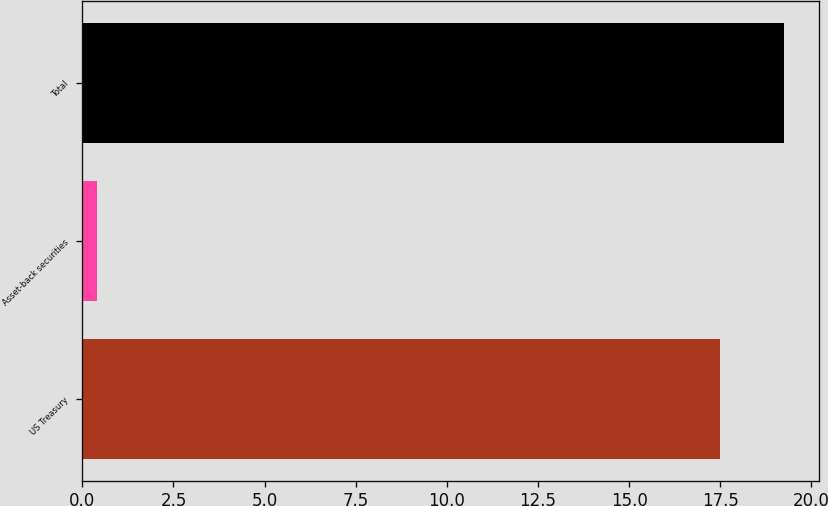Convert chart to OTSL. <chart><loc_0><loc_0><loc_500><loc_500><bar_chart><fcel>US Treasury<fcel>Asset-back securities<fcel>Total<nl><fcel>17.5<fcel>0.4<fcel>19.25<nl></chart> 